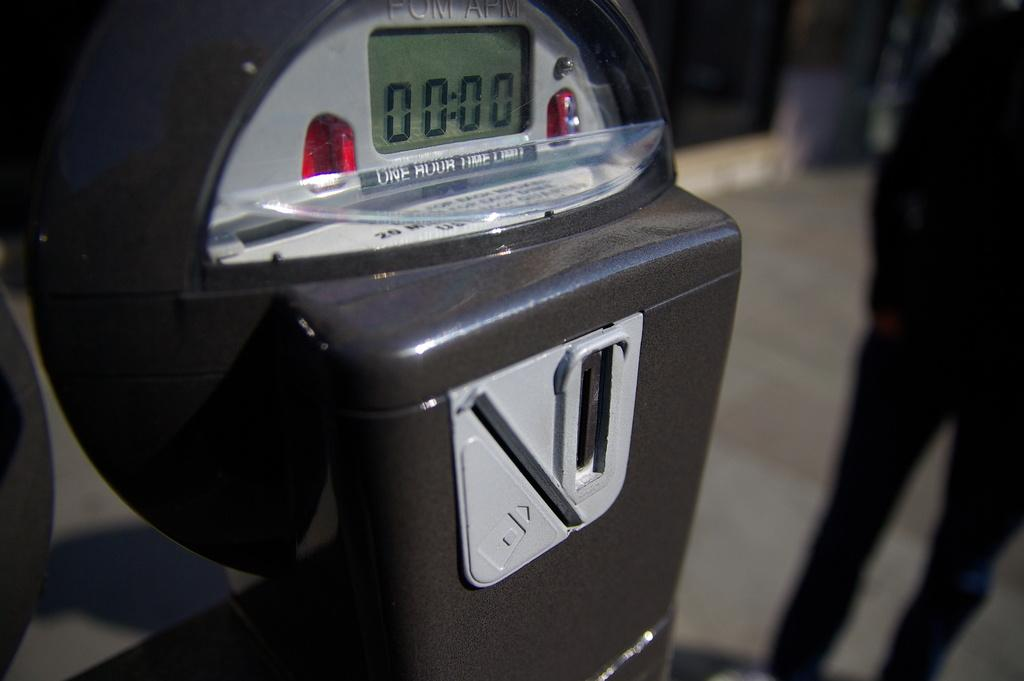<image>
Create a compact narrative representing the image presented. A black parking meter claims a one hour limit. 